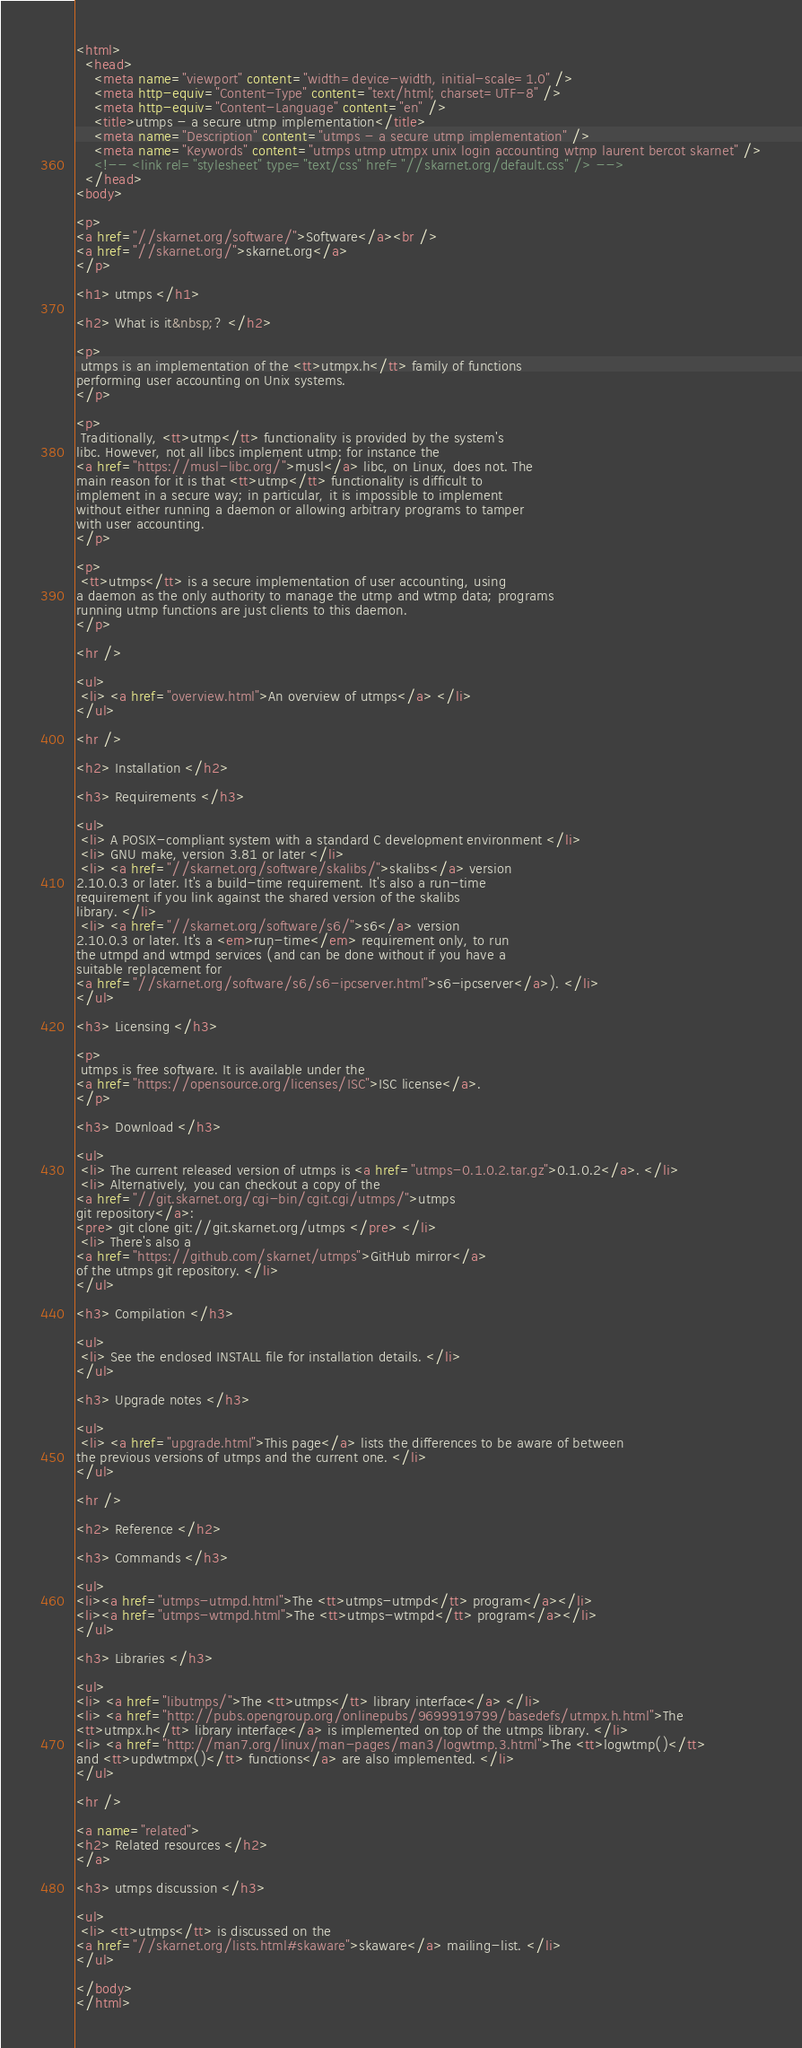Convert code to text. <code><loc_0><loc_0><loc_500><loc_500><_HTML_><html>
  <head>
    <meta name="viewport" content="width=device-width, initial-scale=1.0" />
    <meta http-equiv="Content-Type" content="text/html; charset=UTF-8" />
    <meta http-equiv="Content-Language" content="en" />
    <title>utmps - a secure utmp implementation</title>
    <meta name="Description" content="utmps - a secure utmp implementation" />
    <meta name="Keywords" content="utmps utmp utmpx unix login accounting wtmp laurent bercot skarnet" />
    <!-- <link rel="stylesheet" type="text/css" href="//skarnet.org/default.css" /> -->
  </head>
<body>

<p>
<a href="//skarnet.org/software/">Software</a><br />
<a href="//skarnet.org/">skarnet.org</a>
</p>

<h1> utmps </h1>

<h2> What is it&nbsp;? </h2>

<p>
 utmps is an implementation of the <tt>utmpx.h</tt> family of functions
performing user accounting on Unix systems.
</p>

<p>
 Traditionally, <tt>utmp</tt> functionality is provided by the system's
libc. However, not all libcs implement utmp: for instance the
<a href="https://musl-libc.org/">musl</a> libc, on Linux, does not. The
main reason for it is that <tt>utmp</tt> functionality is difficult to
implement in a secure way; in particular, it is impossible to implement
without either running a daemon or allowing arbitrary programs to tamper
with user accounting.
</p>

<p>
 <tt>utmps</tt> is a secure implementation of user accounting, using
a daemon as the only authority to manage the utmp and wtmp data; programs
running utmp functions are just clients to this daemon.
</p>

<hr />

<ul>
 <li> <a href="overview.html">An overview of utmps</a> </li>
</ul>

<hr />

<h2> Installation </h2>

<h3> Requirements </h3>

<ul>
 <li> A POSIX-compliant system with a standard C development environment </li>
 <li> GNU make, version 3.81 or later </li>
 <li> <a href="//skarnet.org/software/skalibs/">skalibs</a> version
2.10.0.3 or later. It's a build-time requirement. It's also a run-time
requirement if you link against the shared version of the skalibs
library. </li>
 <li> <a href="//skarnet.org/software/s6/">s6</a> version
2.10.0.3 or later. It's a <em>run-time</em> requirement only, to run
the utmpd and wtmpd services (and can be done without if you have a
suitable replacement for
<a href="//skarnet.org/software/s6/s6-ipcserver.html">s6-ipcserver</a>). </li>
</ul>

<h3> Licensing </h3>

<p>
 utmps is free software. It is available under the
<a href="https://opensource.org/licenses/ISC">ISC license</a>.
</p>

<h3> Download </h3>

<ul>
 <li> The current released version of utmps is <a href="utmps-0.1.0.2.tar.gz">0.1.0.2</a>. </li>
 <li> Alternatively, you can checkout a copy of the
<a href="//git.skarnet.org/cgi-bin/cgit.cgi/utmps/">utmps
git repository</a>:
<pre> git clone git://git.skarnet.org/utmps </pre> </li>
 <li> There's also a
<a href="https://github.com/skarnet/utmps">GitHub mirror</a>
of the utmps git repository. </li>
</ul>

<h3> Compilation </h3>

<ul>
 <li> See the enclosed INSTALL file for installation details. </li>
</ul>

<h3> Upgrade notes </h3>

<ul>
 <li> <a href="upgrade.html">This page</a> lists the differences to be aware of between
the previous versions of utmps and the current one. </li>
</ul>

<hr />

<h2> Reference </h2>

<h3> Commands </h3>

<ul>
<li><a href="utmps-utmpd.html">The <tt>utmps-utmpd</tt> program</a></li>
<li><a href="utmps-wtmpd.html">The <tt>utmps-wtmpd</tt> program</a></li>
</ul>

<h3> Libraries </h3>

<ul>
<li> <a href="libutmps/">The <tt>utmps</tt> library interface</a> </li>
<li> <a href="http://pubs.opengroup.org/onlinepubs/9699919799/basedefs/utmpx.h.html">The
<tt>utmpx.h</tt> library interface</a> is implemented on top of the utmps library. </li>
<li> <a href="http://man7.org/linux/man-pages/man3/logwtmp.3.html">The <tt>logwtmp()</tt>
and <tt>updwtmpx()</tt> functions</a> are also implemented. </li>
</ul>

<hr />

<a name="related">
<h2> Related resources </h2>
</a>

<h3> utmps discussion </h3>

<ul>
 <li> <tt>utmps</tt> is discussed on the
<a href="//skarnet.org/lists.html#skaware">skaware</a> mailing-list. </li>
</ul>

</body>
</html>
</code> 